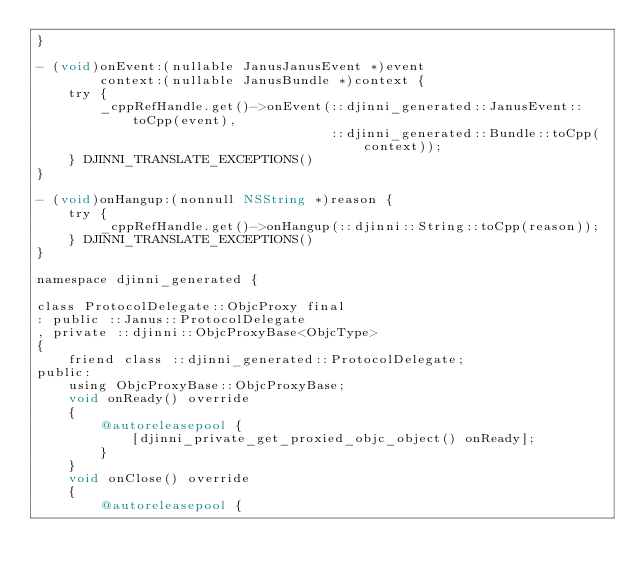<code> <loc_0><loc_0><loc_500><loc_500><_ObjectiveC_>}

- (void)onEvent:(nullable JanusJanusEvent *)event
        context:(nullable JanusBundle *)context {
    try {
        _cppRefHandle.get()->onEvent(::djinni_generated::JanusEvent::toCpp(event),
                                     ::djinni_generated::Bundle::toCpp(context));
    } DJINNI_TRANSLATE_EXCEPTIONS()
}

- (void)onHangup:(nonnull NSString *)reason {
    try {
        _cppRefHandle.get()->onHangup(::djinni::String::toCpp(reason));
    } DJINNI_TRANSLATE_EXCEPTIONS()
}

namespace djinni_generated {

class ProtocolDelegate::ObjcProxy final
: public ::Janus::ProtocolDelegate
, private ::djinni::ObjcProxyBase<ObjcType>
{
    friend class ::djinni_generated::ProtocolDelegate;
public:
    using ObjcProxyBase::ObjcProxyBase;
    void onReady() override
    {
        @autoreleasepool {
            [djinni_private_get_proxied_objc_object() onReady];
        }
    }
    void onClose() override
    {
        @autoreleasepool {</code> 